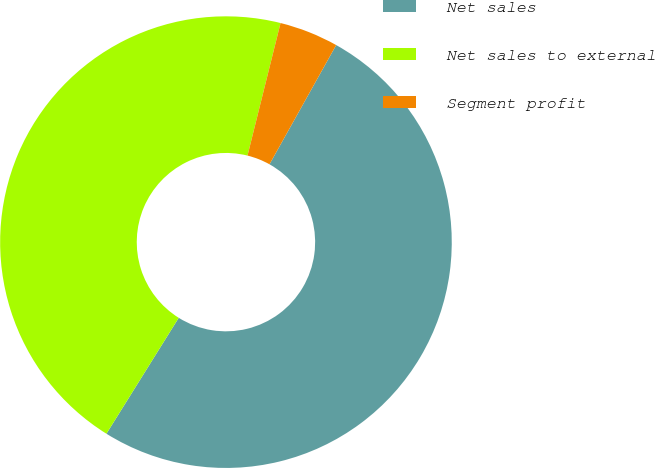Convert chart to OTSL. <chart><loc_0><loc_0><loc_500><loc_500><pie_chart><fcel>Net sales<fcel>Net sales to external<fcel>Segment profit<nl><fcel>50.76%<fcel>45.01%<fcel>4.23%<nl></chart> 